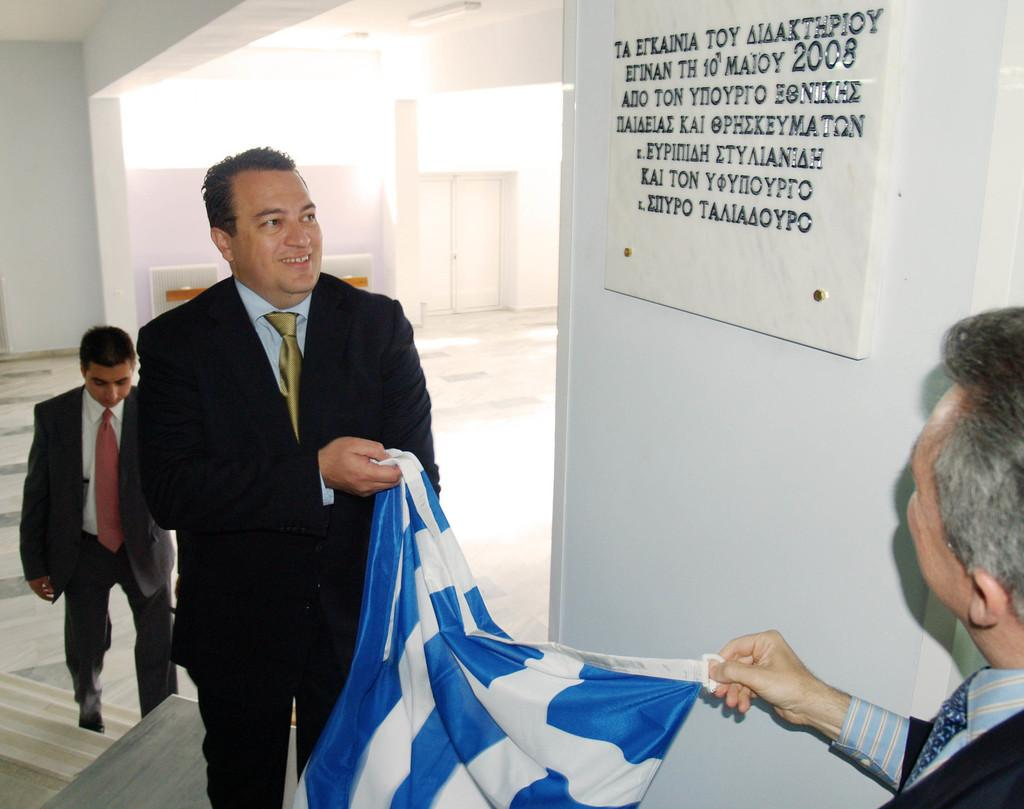What is on the white wall in the image? There is a board on the white wall in the image. What are the two people holding in the image? The two people are holding clothes and looking at the board. Can you describe the setting on the back side of the image? There is a wall and a door on the back side of the image. What are the three people wearing in the image? The three people mentioned are wearing suits and ties. What type of tools is the carpenter using to work on the wax in the image? There is no carpenter or wax present in the image. What type of legal proceedings are the judges overseeing in the image? There is no judge or legal proceedings present in the image. 